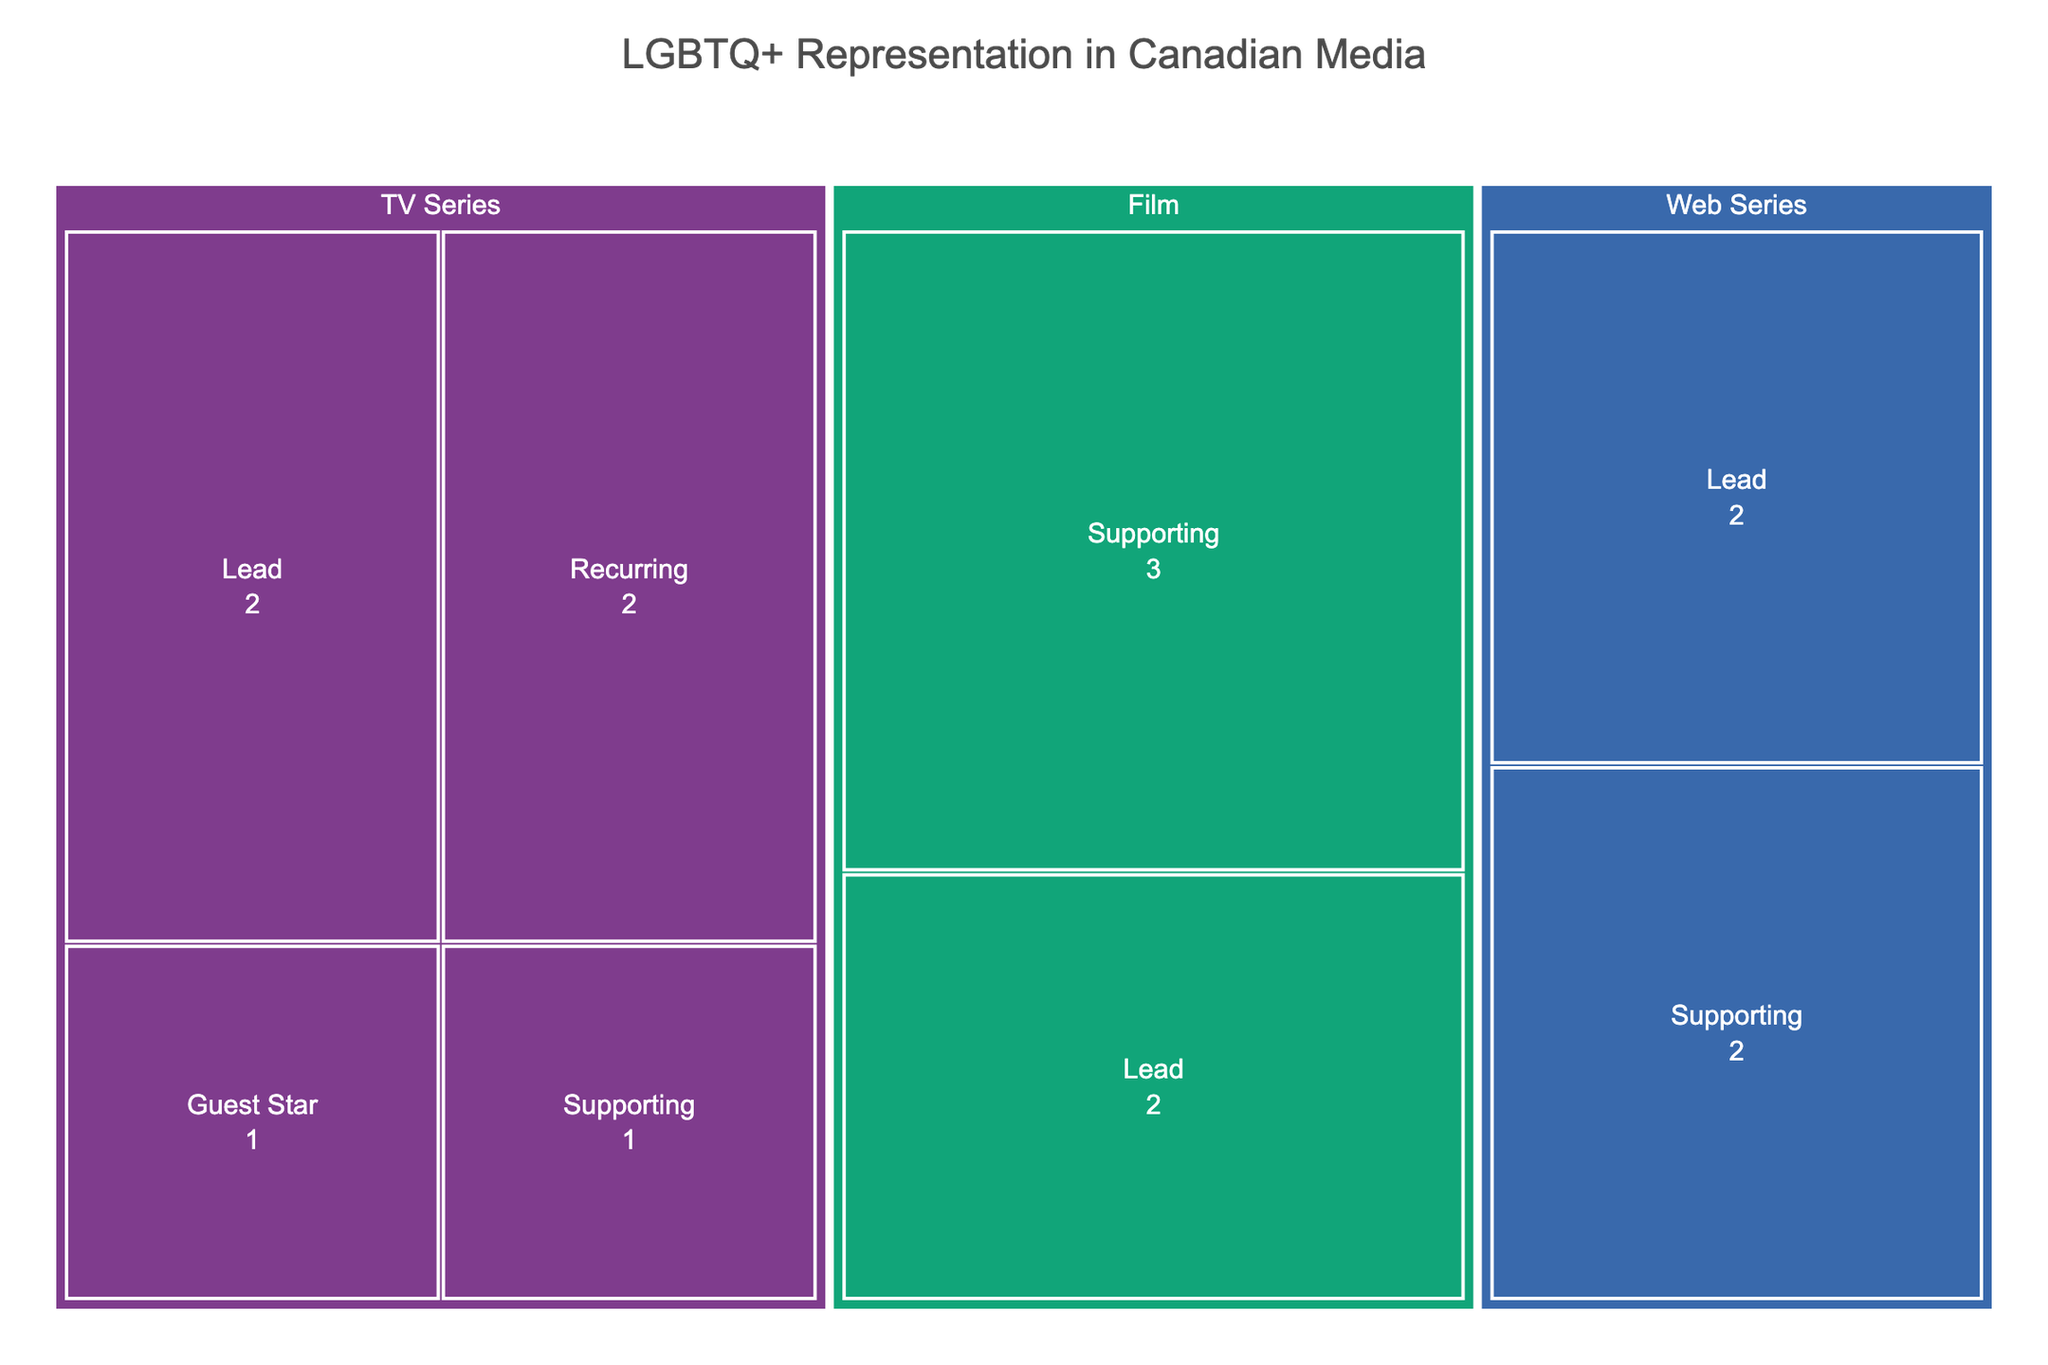What is the title of the figure? The title is usually found at the top of the figure, written in larger and bold text. In this case, the title is "LGBTQ+ Representation in Canadian Media".
Answer: LGBTQ+ Representation in Canadian Media Which media format has the most roles for LGBTQ+ actors? Look at the largest section of the treemap, differentiated by color and labeled "Media Format". Identify which one has the most subdivisions or larger area.
Answer: TV Series How many lead roles are there in web series? Navigate to the section of the treemap labeled "Web Series" and count the number of branches or subdivisions labeled "Lead".
Answer: 2 Compare the number of lead roles in TV series and films. Which has more? Check both the "TV Series" and "Film" sections and count the branches labeled "Lead" in each. Compare these counts to see which is higher.
Answer: TV Series What is the breakdown of character types in films? Locate the "Film" section and identify each branch within it, noting the character types (Lead, Supporting, etc.) and their respective counts.
Answer: Lead: 2, Supporting: 3 Which character type appears the most in web series? Look at the "Web Series" section and count the occurrences of each character type. Determine which one has the highest count.
Answer: Supporting Are there more supporting roles in TV series or films? Identify the number of supporting roles within the "TV Series" section and the "Film" section. Compare these numbers to determine which has more.
Answer: TV Series What is the total number of guest star roles across all media formats? Look for sections labeled "Guest Star" across the entire treemap and sum their counts. This involves counting only the "Guest Star" values within each media format.
Answer: 1 Which media format has the least representation for LGBTQ+ actors? Identify the smallest colored section in the treemap representing media formats. This would indicate the least representation.
Answer: Web Series What is the ratio of recurring roles to lead roles in TV series? Count the number of "Recurring" and "Lead" roles in the "TV Series" section and then divide the recurring roles by the lead roles to get the ratio.
Answer: 2:3 (or 0.67) 